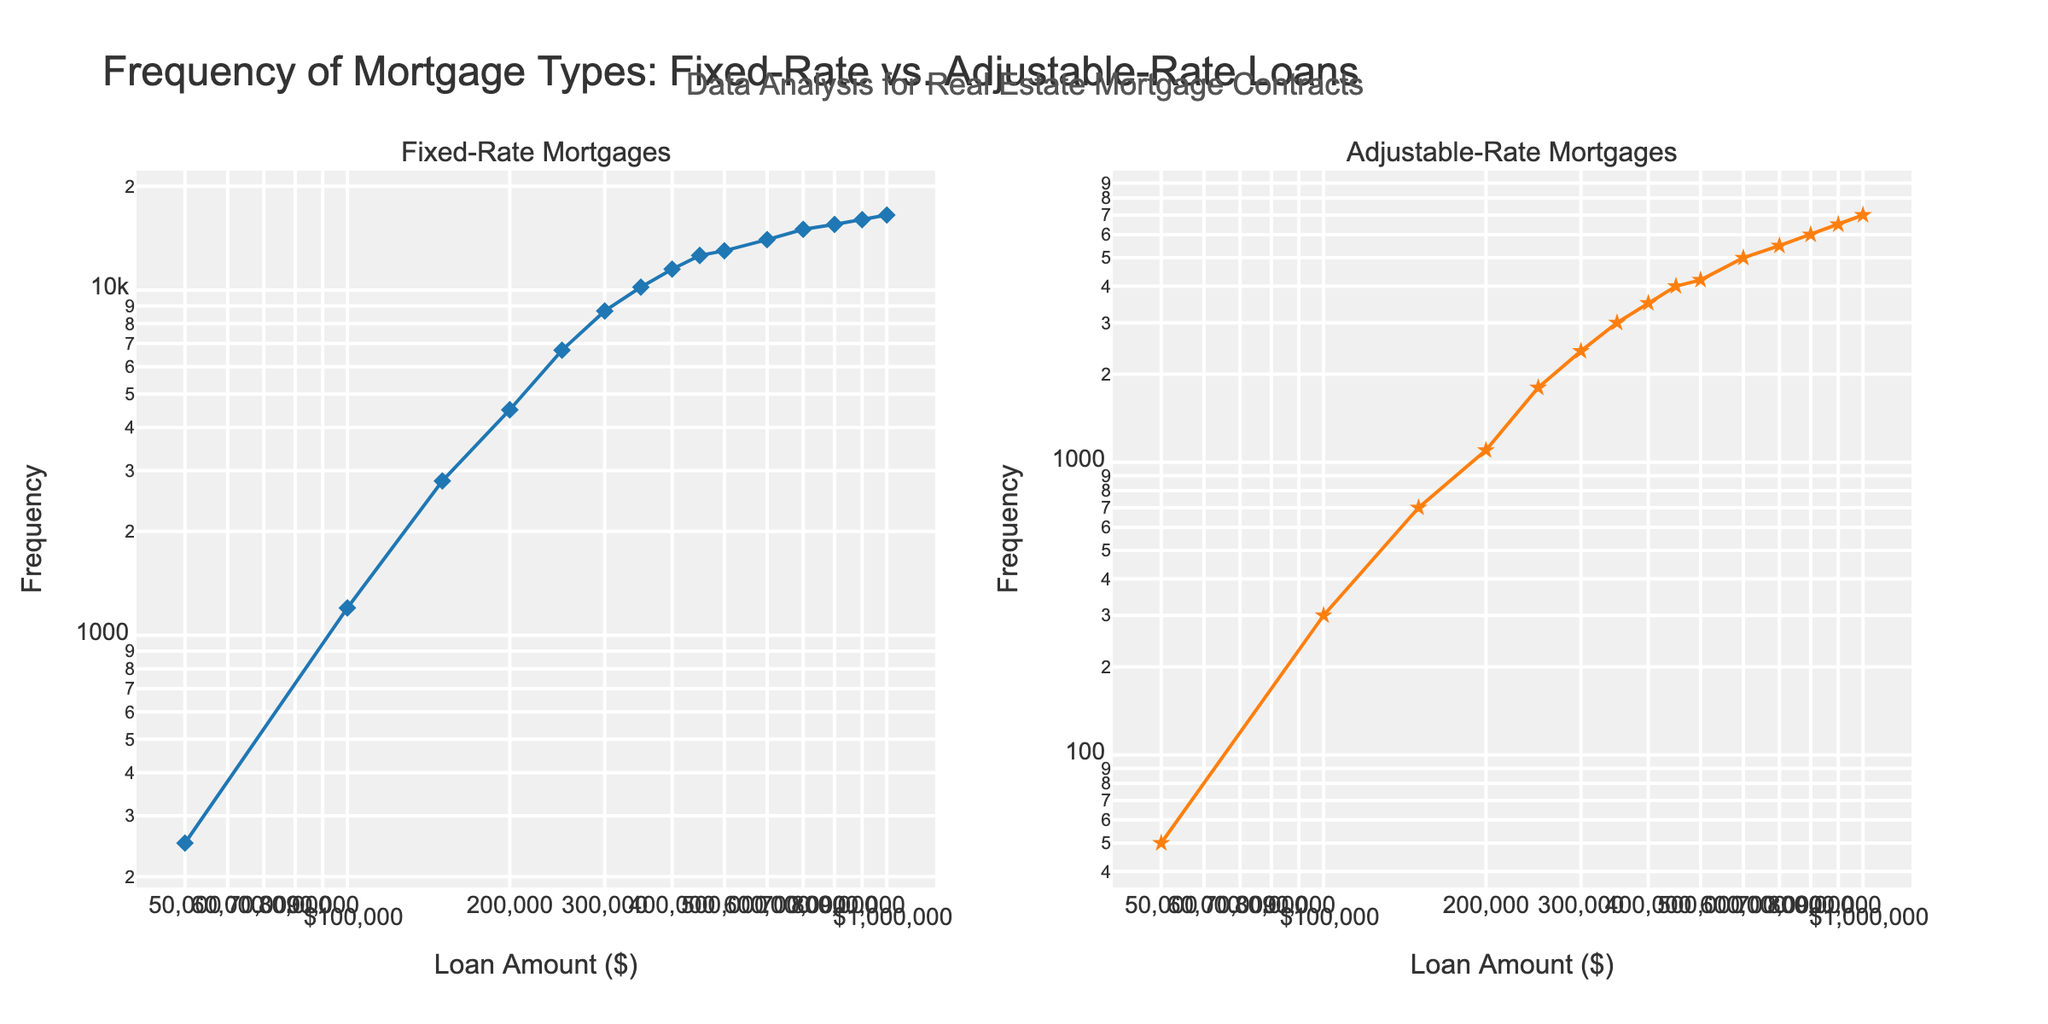What's the title of the plot? The title is located at the top center of the plot. It reads "Frequency of Mortgage Types: Fixed-Rate vs. Adjustable-Rate Loans."
Answer: Frequency of Mortgage Types: Fixed-Rate vs. Adjustable-Rate Loans What are the x-axis and y-axis titles? The x-axis title for both subplots is "Loan Amount ($)" and the y-axis title is "Frequency". These titles are displayed on the bottom and left side of the plots, respectively.
Answer: Loan Amount ($) and Frequency Which mortgage type generally has a higher frequency, according to the figure? By looking at the values plotted on the y-axis for both subplots, you can see that the Fixed-Rate Mortgages subplot consistently shows higher frequency values compared to the Adjustable-Rate Mortgages subplot.
Answer: Fixed-Rate Mortgages What are the loan amounts where Fixed-Rate Mortgages have the same frequency? By examining the data points, Fixed-Rate Mortgages have the same frequency at loan amounts of $500,000 and $600,000, both with a frequency of 14000.
Answer: $500,000 and $600,000 At what loan amount do Adjustable-Rate Mortgages have a frequency of around 4000? By observing the subplot on the right (Adjustable-Rate Mortgages), the frequency of 4000 occurs at a loan amount of $450,000.
Answer: $450,000 What is the overall trend observed for both mortgage types as the loan amount increases? For both Fixed-Rate and Adjustable-Rate Mortgages, the frequency generally increases as the loan amount increases. This trend is evident by following the upward trajectory of the lines in both subplots.
Answer: Frequency increases with loan amount At a loan amount of $100,000, how does the frequency of Fixed-Rate Mortgages compare to Adjustable-Rate Mortgages? From the subplots, at $100,000 the frequency of Fixed-Rate Mortgages is 1200, whereas Adjustable-Rate Mortgages have a frequency of 300. Fixed-Rate is four times higher.
Answer: Fixed-Rate is higher Which mortgage type has a larger increase in frequency when the loan amount increases from $50,000 to $1,000,000? By calculating the difference in frequencies, Fixed-Rate Mortgages increase from 250 to 16500 (16250 increase), and Adjustable-Rate Mortgages increase from 50 to 7000 (6950 increase). Therefore, Fixed-Rate Mortgages have a larger increase.
Answer: Fixed-Rate Mortgages What loan amount does Fixed-Rate Mortgages reach the frequency of 8700? From the Fixed-Rate Mortgages subplot, the frequency of 8700 is reached at a loan amount of $300,000.
Answer: $300,000 Is the relationship between loan amounts and frequencies linear or non-linear? Given that the scales of both the x and y axes are logarithmic, the straight-line appearance in the subplots indicates that the relationship between loan amounts and frequencies is exponential, which is non-linear.
Answer: Non-linear 